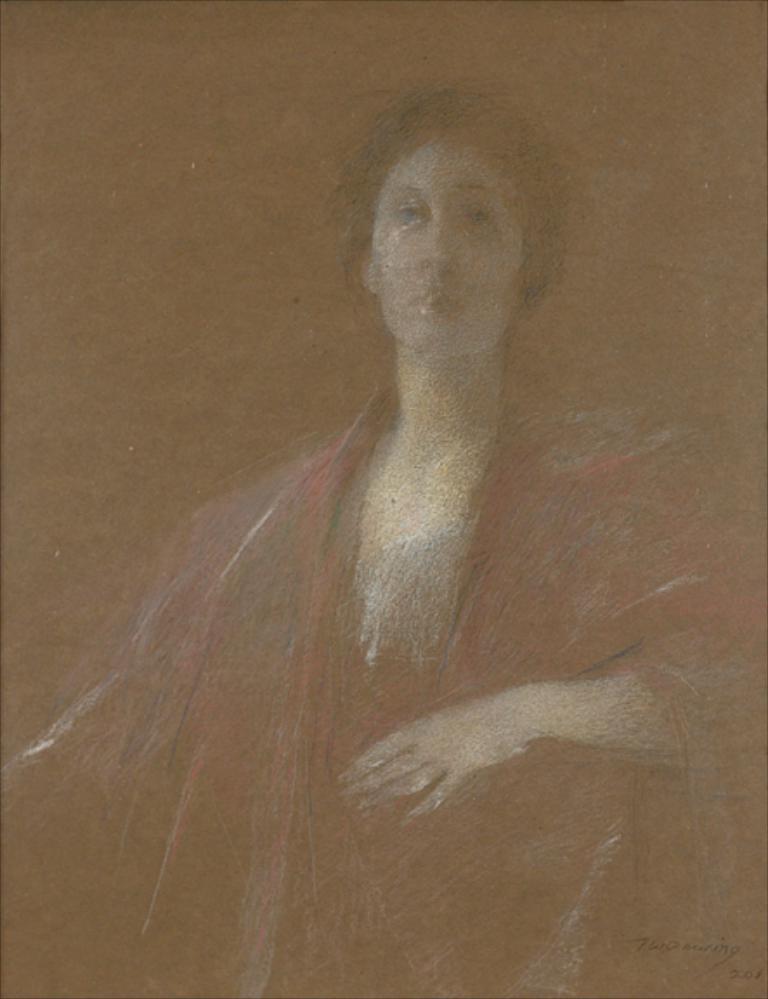Describe this image in one or two sentences. This is a blur image of a painting. I can see a woman in this painting and in the bottom right corner I can see some text. 